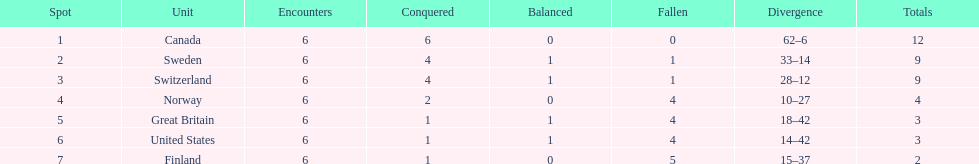Could you parse the entire table as a dict? {'header': ['Spot', 'Unit', 'Encounters', 'Conquered', 'Balanced', 'Fallen', 'Divergence', 'Totals'], 'rows': [['1', 'Canada', '6', '6', '0', '0', '62–6', '12'], ['2', 'Sweden', '6', '4', '1', '1', '33–14', '9'], ['3', 'Switzerland', '6', '4', '1', '1', '28–12', '9'], ['4', 'Norway', '6', '2', '0', '4', '10–27', '4'], ['5', 'Great Britain', '6', '1', '1', '4', '18–42', '3'], ['6', 'United States', '6', '1', '1', '4', '14–42', '3'], ['7', 'Finland', '6', '1', '0', '5', '15–37', '2']]} How many teams won at least 4 matches? 3. 